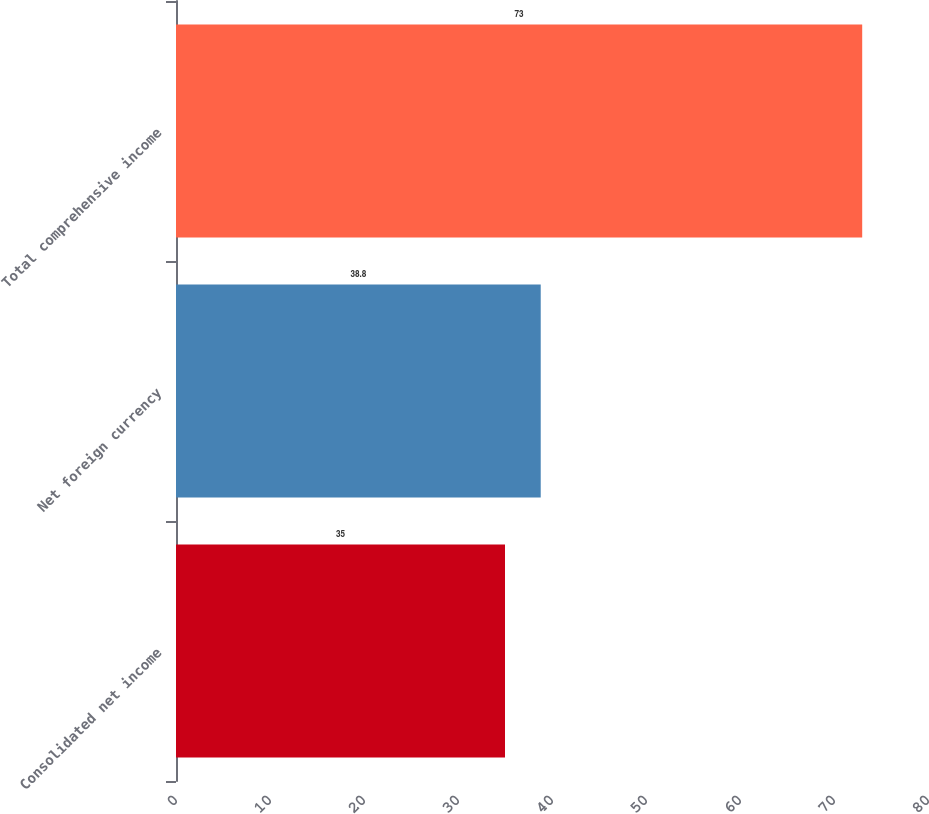<chart> <loc_0><loc_0><loc_500><loc_500><bar_chart><fcel>Consolidated net income<fcel>Net foreign currency<fcel>Total comprehensive income<nl><fcel>35<fcel>38.8<fcel>73<nl></chart> 